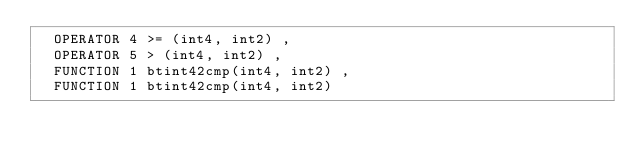Convert code to text. <code><loc_0><loc_0><loc_500><loc_500><_SQL_>  OPERATOR 4 >= (int4, int2) ,
  OPERATOR 5 > (int4, int2) ,
  FUNCTION 1 btint42cmp(int4, int2) ,
  FUNCTION 1 btint42cmp(int4, int2)
</code> 